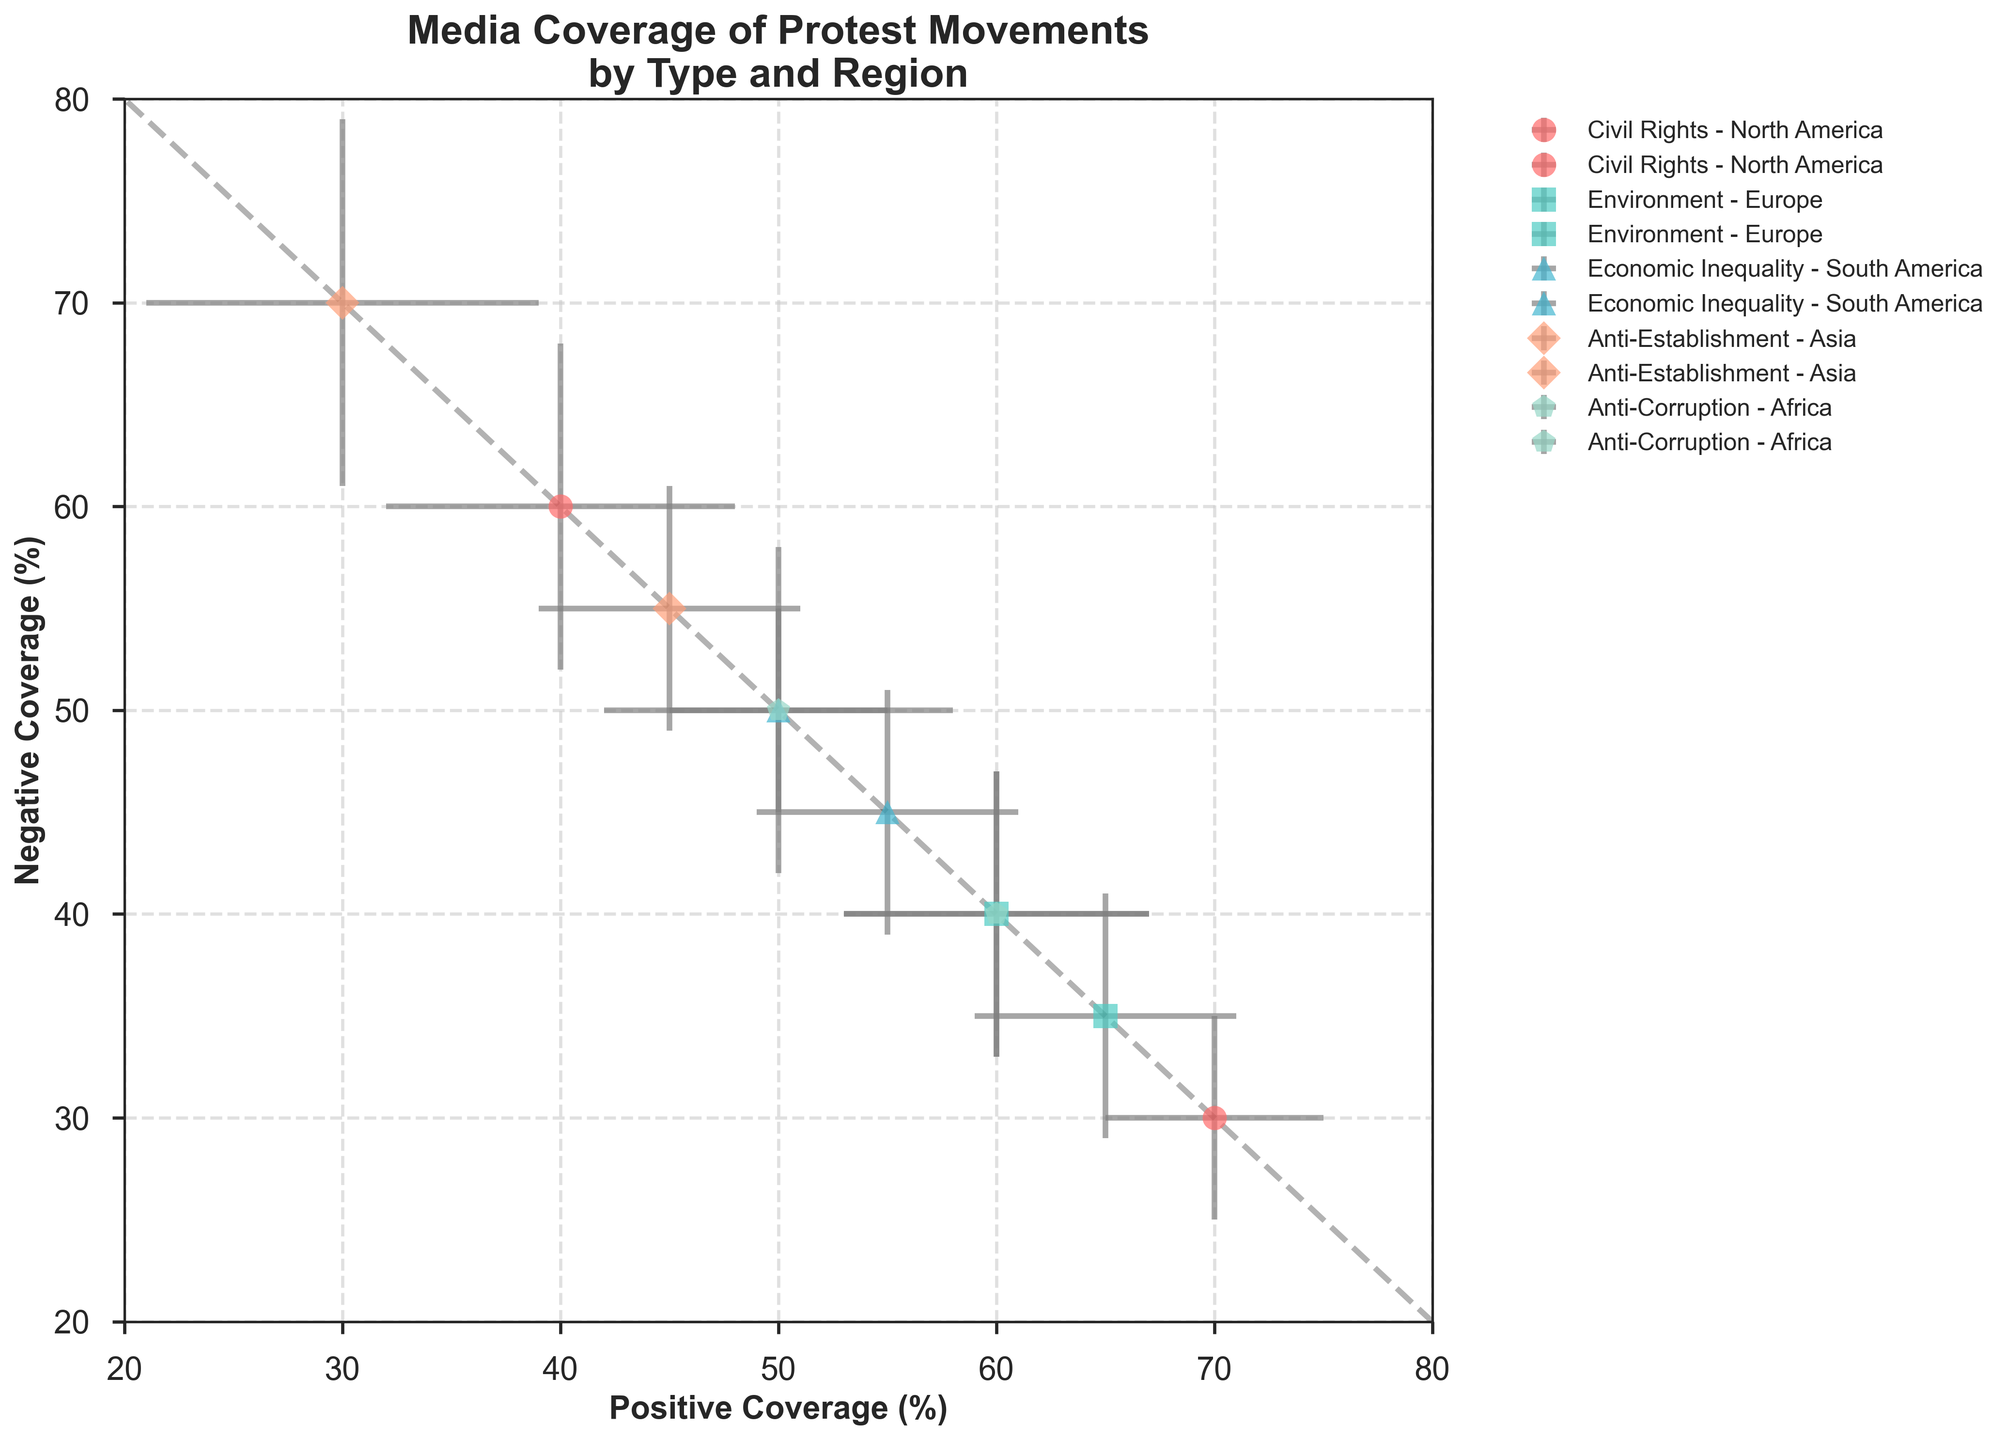What is the title of the figure? The title usually appears at the top of the plot. It's written clearly to inform viewers about the plot's main topic. Here the title reads 'Media Coverage of Protest Movements by Type and Region'.
Answer: Media Coverage of Protest Movements by Type and Region What are the x and y-axis labels? The x and y-axis labels are essential for understanding what the axes represent. The x-axis label is 'Positive Coverage (%)', and the y-axis label is 'Negative Coverage (%)'.
Answer: Positive Coverage (%) and Negative Coverage (%) Which region has the highest positive coverage for Civil Rights protests? To find this, look for the region-specific marker (o for North America) and the color corresponding to Civil Rights (#FF6B6B). CNN with 70% positive coverage is from North America.
Answer: North America What's the median value of sentiment error margin for Anti-Corruption protests? The sentiment error margins for Anti-Corruption from Al Jazeera and Daily Nation are 7 and 8. Calculating the median of these values, we get (7, 8), median is 7.5.
Answer: 7.5 Which media outlet has the widest sentiment error margin for Anti-Establishment protests? Anti-Establishment is orange (#FFA07A). Comparing the error margins for Anti-Establishment, CCTV has a margin of 9 and The Asahi Shimbun has 6. CCTV has a wider margin.
Answer: CCTV Which protest type has the most consistent media coverage in South America? Look for markers specific to South America (^). Compare the error bars for Economic Inequality in Telesur and O Globo. Both have relatively smaller error margins (6 and 5). Economic Inequality has consistent media coverage.
Answer: Economic Inequality Do BBC News and Deutsche Welle have a similar sentiment error margin for Environment protests? Both belong to Environment protest type in Europe. BBC News has a margin of 6, and Deutsche Welle has 7. The margins are close but not exact.
Answer: No Which comparison, positive or negative coverage, shows greater variability among Asian media outlets for Anti-Establishment protests? Look at Anti-Establishment in Asia (orange, diamond markers). Positive coverage values are 30 (CCTV) and 45 (The Asahi Shimbun), showing a difference of 15%. Negative coverage values are 70 (CCTV) and 55 (The Asahi Shimbun), a difference of 15%. Both show equal variability.
Answer: Equal Which region demonstrates the most balanced (50-50) media coverage for any protest type? Balanced coverage means equal parts positive and negative. O Globo in South America (Economic Inequality) and Daily Nation in Africa (Anti-Corruption) both show a 50-50 split.
Answer: South America and Africa Are there any protest types where the error bars overlap among different regions, indicating similar sentiment variability? Overlapping error bars imply comparable sentiment variability. Civil Rights in North America (CNN and Fox News) and Anti-Corruption in Africa (Al Jazeera, Daily Nation) show overlapping error bars, indicating similar sentiment variabilities.
Answer: Yes 